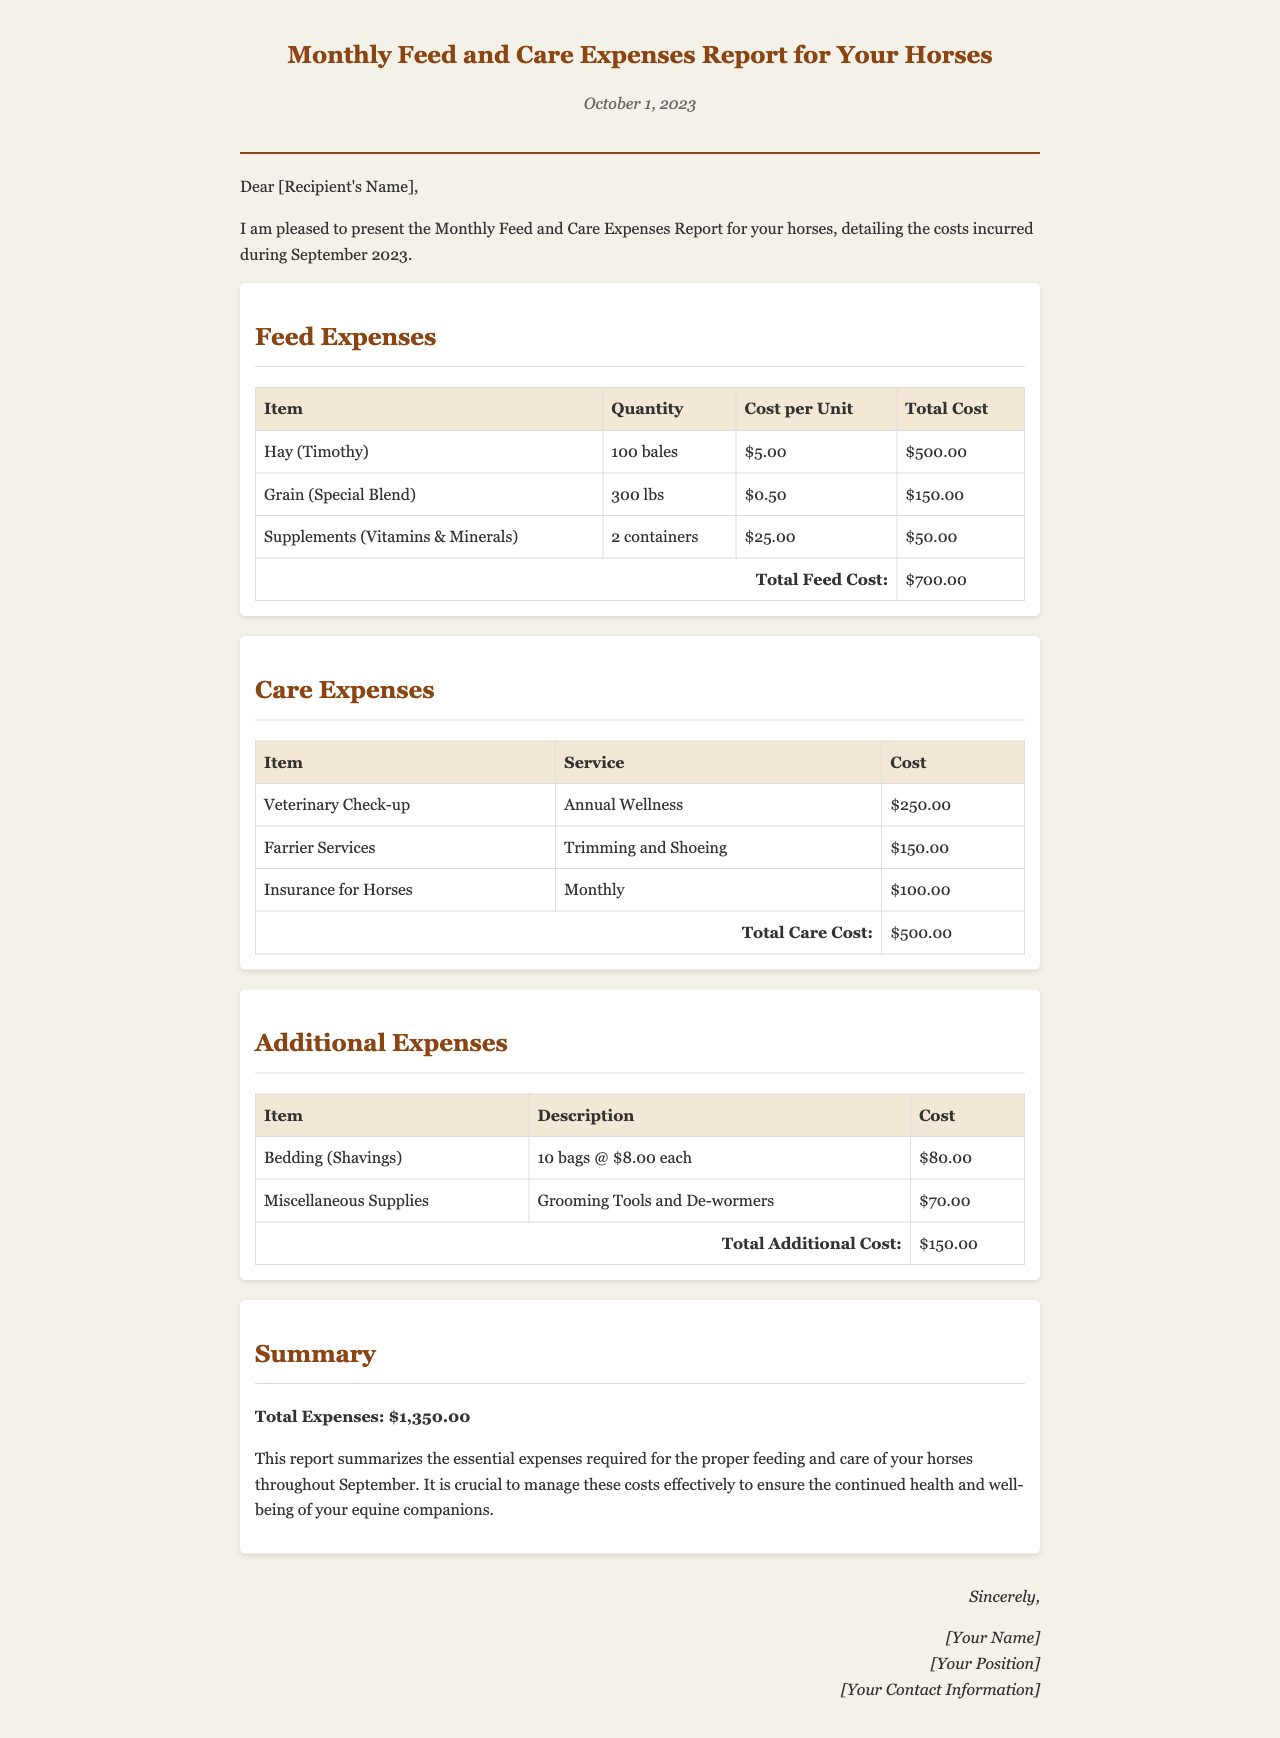what is the total feed cost? The total feed cost is calculated by summing the costs of all feed items listed in the report. The total feed cost is $500.00 + $150.00 + $50.00 = $700.00.
Answer: $700.00 what service does the veterinary check-up refer to? The veterinary check-up refers to the Annual Wellness service as mentioned in the care expenses table.
Answer: Annual Wellness how many bales of hay were purchased? The quantity of hay purchased is specified in the feed expenses table, which states 100 bales of hay (Timothy).
Answer: 100 bales what is the total care cost? The total care cost is calculated by adding up the individual costs from the care expenses section. The total care cost is $250.00 + $150.00 + $100.00 = $500.00.
Answer: $500.00 how much did the miscellaneous supplies cost? The cost of miscellaneous supplies is provided in the additional expenses table, indicating it was $70.00.
Answer: $70.00 what is the total amount paid for bedding? The bedding cost appears in the additional expenses section and states 10 bags at $8.00 each, totaling $80.00.
Answer: $80.00 what is the total monthly expense reported? The summary section outlines the total expenses which include feed, care, and additional costs, totaling $1,350.00.
Answer: $1,350.00 who prepared the report? The signature section at the end of the report would typically include the preparer's name, position, and contact information, denoted by [Your Name].
Answer: [Your Name] 